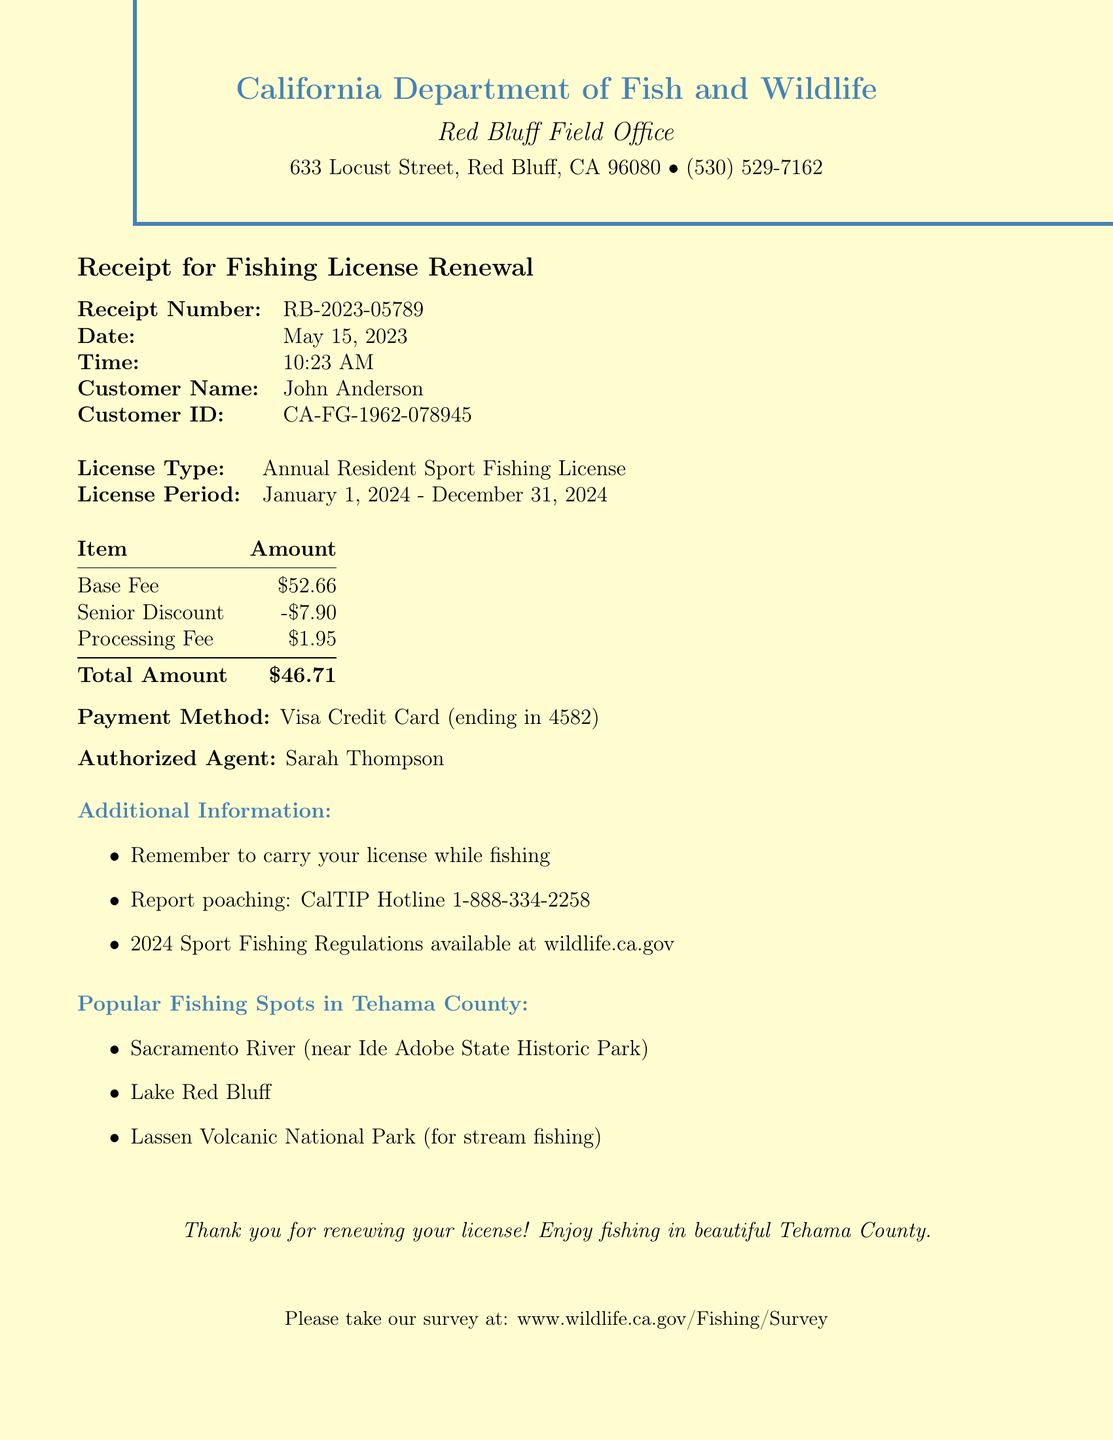What is the receipt number? The receipt number can be found at the top of the document as an identifier for the transaction.
Answer: RB-2023-05789 What is the date of the transaction? The date is stated clearly beside the receipt number, indicating when the transaction took place.
Answer: May 15, 2023 What is the total amount paid? The total amount is found at the bottom of the fee breakdown section, summarizing the payment made.
Answer: $46.71 What is the license type? The license type can be found in the section detailing the nature of the fishing license obtained.
Answer: Annual Resident Sport Fishing License What discount was applied? The discount is mentioned as part of the fee breakdown, specifically indicating any reductions for the customer.
Answer: -$7.90 Who was the authorized agent? The authorized agent's name appears in the document, representing the person who processed the renewal.
Answer: Sarah Thompson What payment method was used? The payment method states the type of payment and the last few digits of the card used for the transaction.
Answer: Visa Credit Card (ending in 4582) What are popular fishing spots in Tehama County? The document lists specific locations as recommended spots for fishing in the area covered by the license.
Answer: Sacramento River, Lake Red Bluff, Lassen Volcanic National Park What is the license period? The license period specifies the valid duration of the fishing license, usually indicating when the license can be used.
Answer: January 1, 2024 - December 31, 2024 